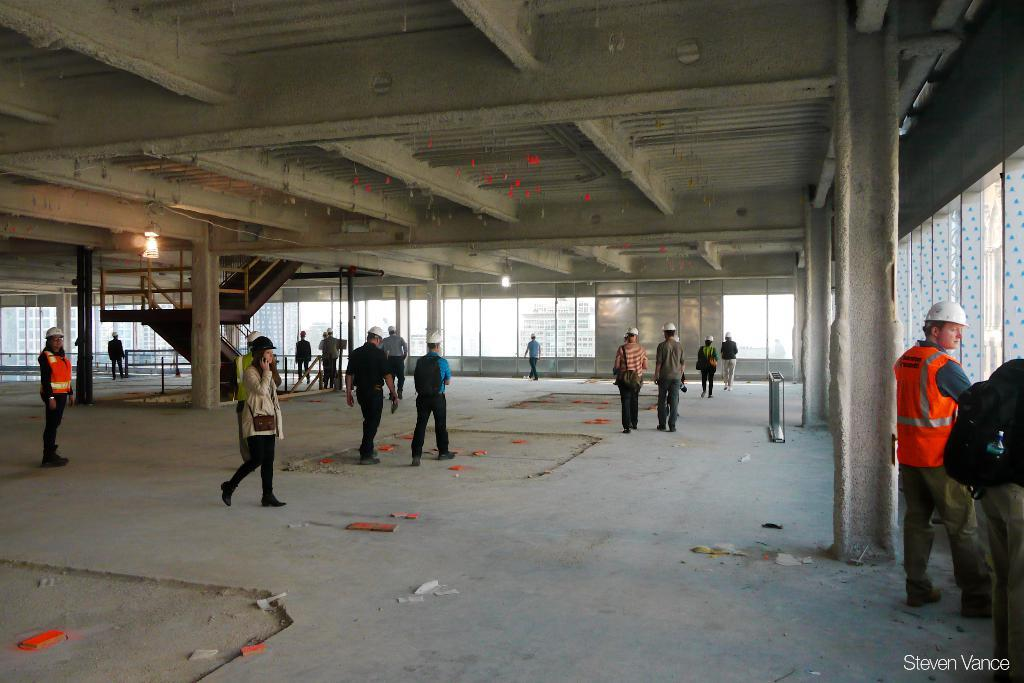What is the setting of the image? There are people standing in a building. What safety equipment can be seen on some of the people? Two people are wearing life jackets, and some people are wearing helmets. Can you describe any architectural features in the image? There are stairs in the image. Where is the faucet located in the image? There is no faucet present in the image. Can you describe the running activity in the image? There is no running activity depicted in the image. 